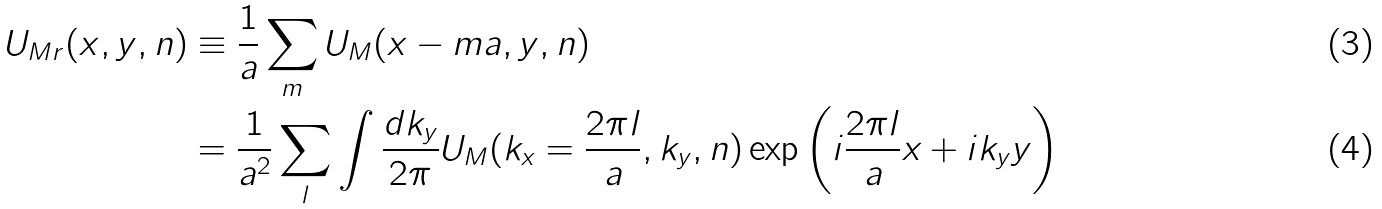Convert formula to latex. <formula><loc_0><loc_0><loc_500><loc_500>U _ { M r } ( x , y , n ) & \equiv \frac { 1 } { a } \sum _ { m } U _ { M } ( x - m a , y , n ) \\ & = \frac { 1 } { a ^ { 2 } } \sum _ { l } \int \frac { d k _ { y } } { 2 \pi } U _ { M } ( k _ { x } = \frac { 2 \pi l } { a } , k _ { y } , n ) \exp \left ( i \frac { 2 \pi l } { a } x + i k _ { y } y \right )</formula> 